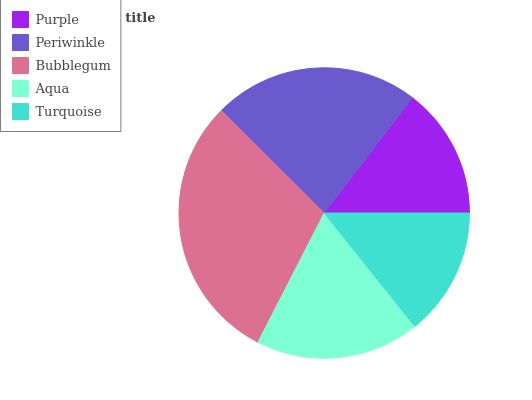Is Turquoise the minimum?
Answer yes or no. Yes. Is Bubblegum the maximum?
Answer yes or no. Yes. Is Periwinkle the minimum?
Answer yes or no. No. Is Periwinkle the maximum?
Answer yes or no. No. Is Periwinkle greater than Purple?
Answer yes or no. Yes. Is Purple less than Periwinkle?
Answer yes or no. Yes. Is Purple greater than Periwinkle?
Answer yes or no. No. Is Periwinkle less than Purple?
Answer yes or no. No. Is Aqua the high median?
Answer yes or no. Yes. Is Aqua the low median?
Answer yes or no. Yes. Is Bubblegum the high median?
Answer yes or no. No. Is Purple the low median?
Answer yes or no. No. 